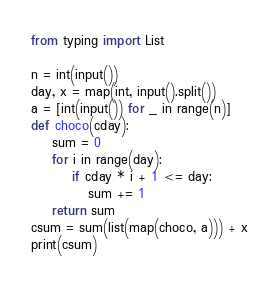Convert code to text. <code><loc_0><loc_0><loc_500><loc_500><_Python_>from typing import List

n = int(input())
day, x = map(int, input().split())
a = [int(input()) for _ in range(n)]
def choco(cday):
    sum = 0
    for i in range(day):
        if cday * i + 1 <= day:
           sum += 1
    return sum
csum = sum(list(map(choco, a))) + x
print(csum)
</code> 